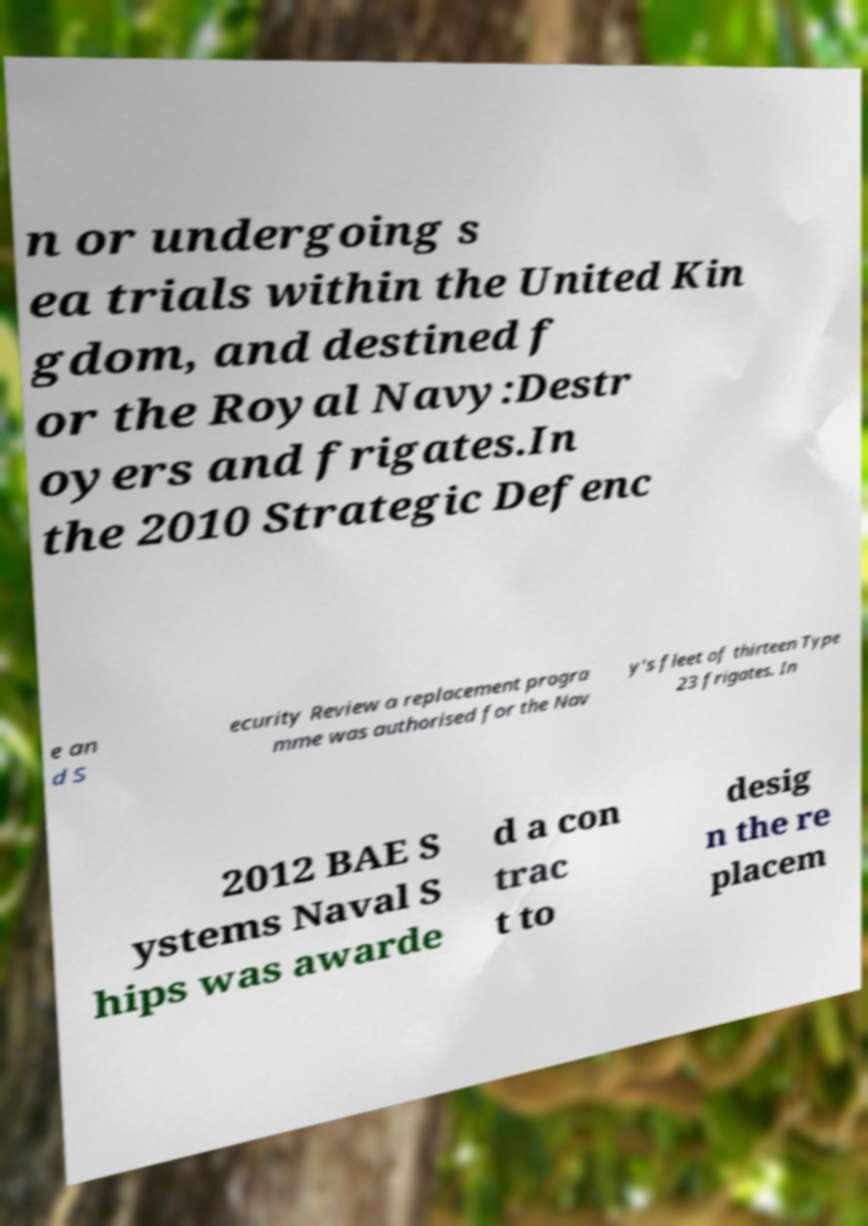Please read and relay the text visible in this image. What does it say? n or undergoing s ea trials within the United Kin gdom, and destined f or the Royal Navy:Destr oyers and frigates.In the 2010 Strategic Defenc e an d S ecurity Review a replacement progra mme was authorised for the Nav y's fleet of thirteen Type 23 frigates. In 2012 BAE S ystems Naval S hips was awarde d a con trac t to desig n the re placem 